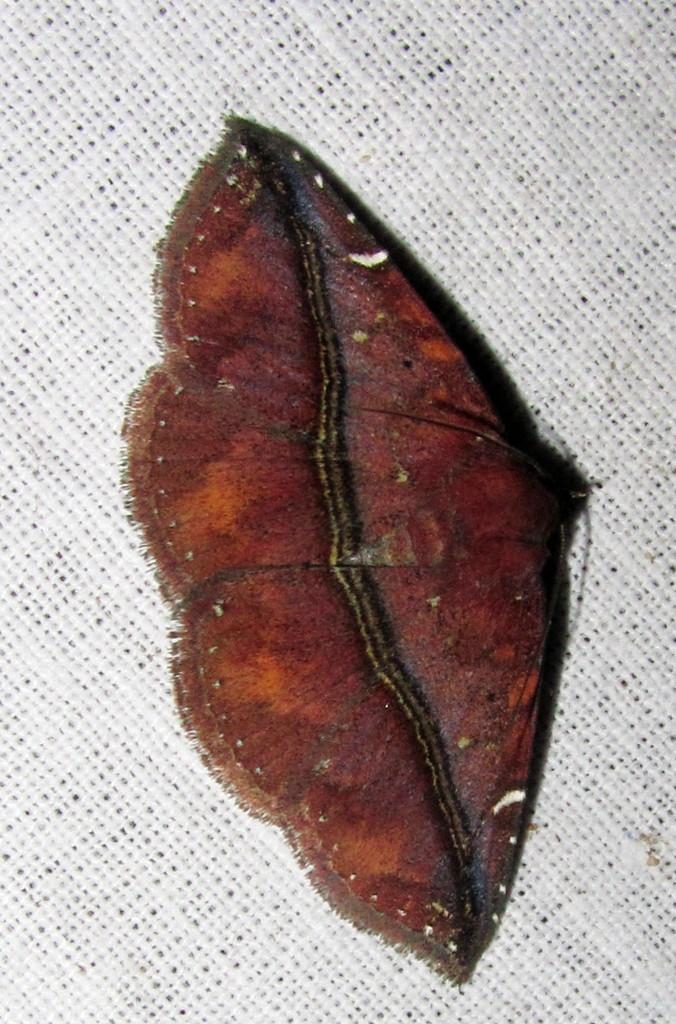In one or two sentences, can you explain what this image depicts? In this image we can see a brown color insect on the white color surface. 